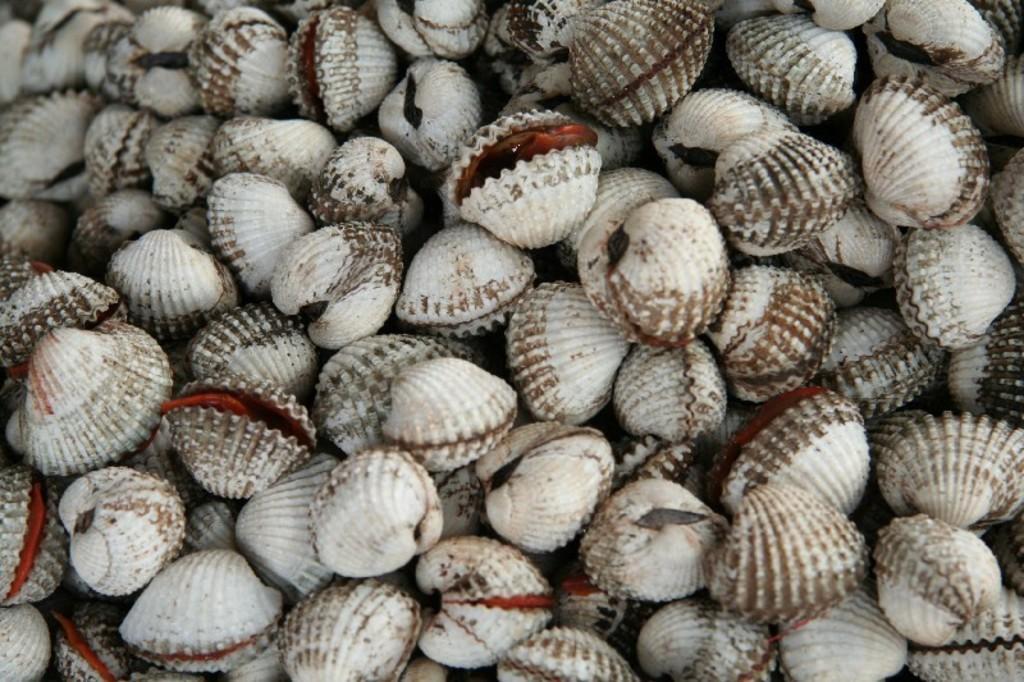How would you summarize this image in a sentence or two? In this picture we can see a group of shells. 